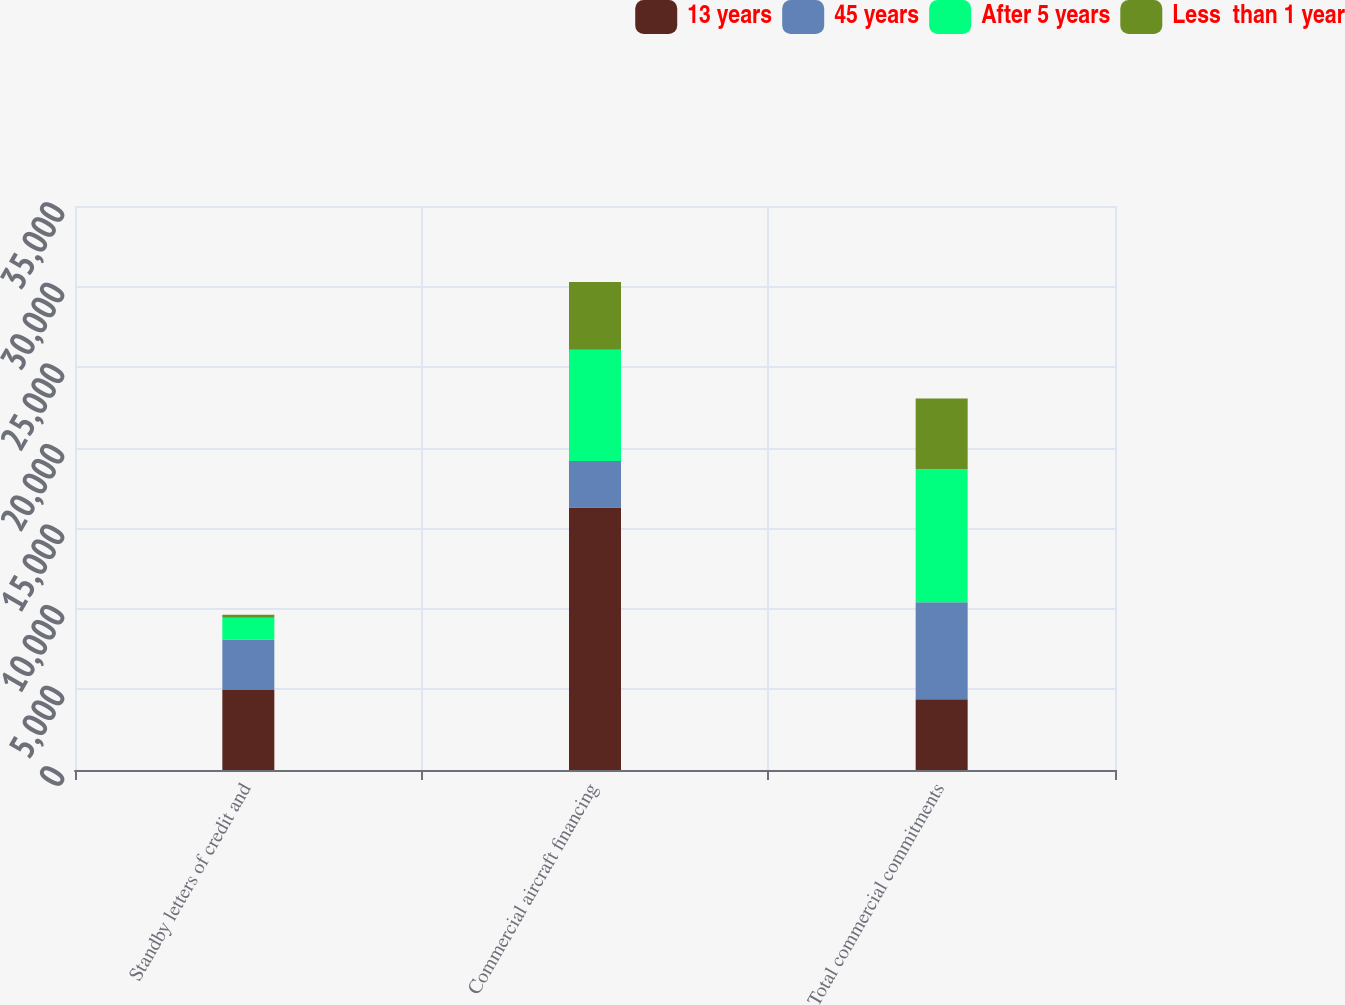Convert chart to OTSL. <chart><loc_0><loc_0><loc_500><loc_500><stacked_bar_chart><ecel><fcel>Standby letters of credit and<fcel>Commercial aircraft financing<fcel>Total commercial commitments<nl><fcel>13 years<fcel>4968<fcel>16283<fcel>4387<nl><fcel>45 years<fcel>3127<fcel>2897<fcel>6024<nl><fcel>After 5 years<fcel>1355<fcel>6899<fcel>8254<nl><fcel>Less  than 1 year<fcel>182<fcel>4205<fcel>4387<nl></chart> 